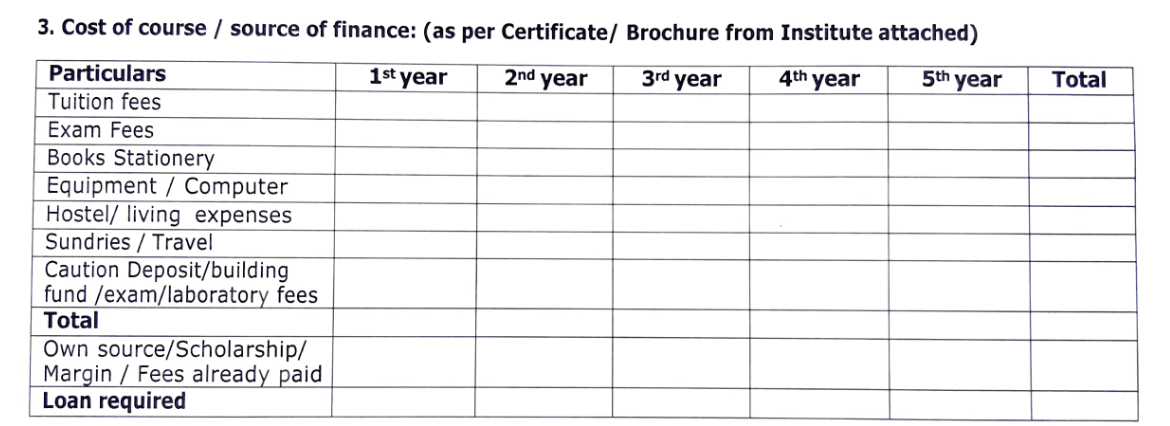create the table given in the image in markdown | Particulars | 1<sup>st</sup> year | 2<sup>nd</sup> year | 3<sup>rd</sup> year | 4<sup>th</sup> year | 5<sup>th</sup> year | Total |
|---|---|---|---|---|---|---|
| Tuition fees |  |  |  |  |  |  |
| Exam Fees |  |  |  |  |  |  |
| Books Stationery |  |  |  |  |  |  |
| Equipment / Computer |  |  |  |  |  |  |
| Hostel/ living expenses |  |  |  |  |  |  |
| Sundries / Travel |  |  |  |  |  |  |
| Caution Deposit/building fund /exam/laboratory fees |  |  |  |  |  |  |
| **Total** |  |  |  |  |  |  |
| Own source/Scholarship/ Margin / Fees already paid |  |  |  |  |  |  |
| **Loan required** |  |  |  |  |  |  | 